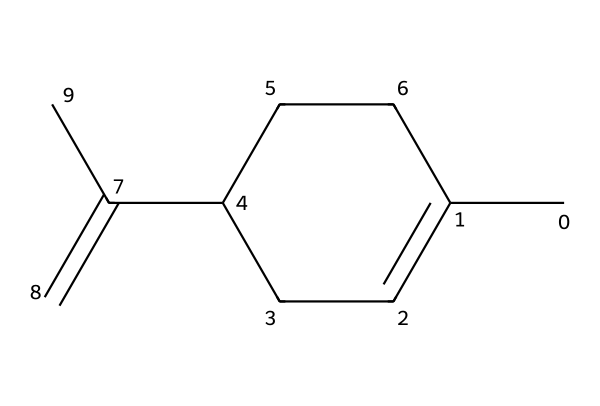What is the molecular formula of limonene? By analyzing the SMILES representation, we can count the number of carbon (C) and hydrogen (H) atoms. The chemical structure has 10 carbon atoms and 16 hydrogen atoms, leading to the molecular formula C10H16.
Answer: C10H16 How many rings does limonene have? The structure depicted in the SMILES indicates a cyclic arrangement of the carbon atoms, specifically one ring. We can see that there are cyclic bonds formed, confirming there is one ring in the structure.
Answer: one What is the structure type of limonene? Limonene is categorized as a cyclic terpene based on its structure, which consists of a closed carbon ring typical of cycloalkanes and contains double bonds typical for terpenes.
Answer: cyclic terpene How many double bonds are present in limonene? Upon examining the molecular structure, we see that there are two double bonds indicated in the arrangement, further specified by C(=C) within the SMILES notation.
Answer: two Does limonene contain any functional groups? Investigating the structure shows that limonene does not contain any functional groups like -OH or -COOH; it only contains carbon and hydrogen, qualifying it as an alkene due to the double bonds.
Answer: no What type of isomerism might limonene exhibit? Given that limonene has a specific arrangement of atoms with a ring structure and double bonds, it can exhibit geometric isomerism, particularly cis-trans isomerism, because of the restricted rotation around the double bonds.
Answer: geometric isomerism 